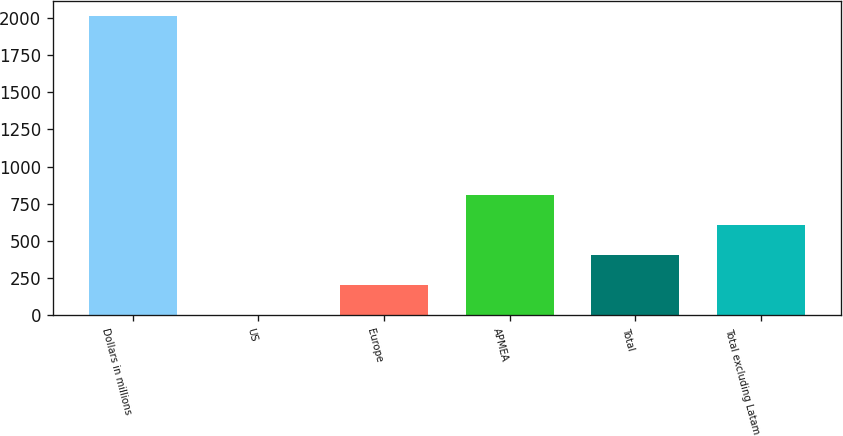<chart> <loc_0><loc_0><loc_500><loc_500><bar_chart><fcel>Dollars in millions<fcel>US<fcel>Europe<fcel>APMEA<fcel>Total<fcel>Total excluding Latam<nl><fcel>2009<fcel>6<fcel>206.3<fcel>807.2<fcel>406.6<fcel>606.9<nl></chart> 